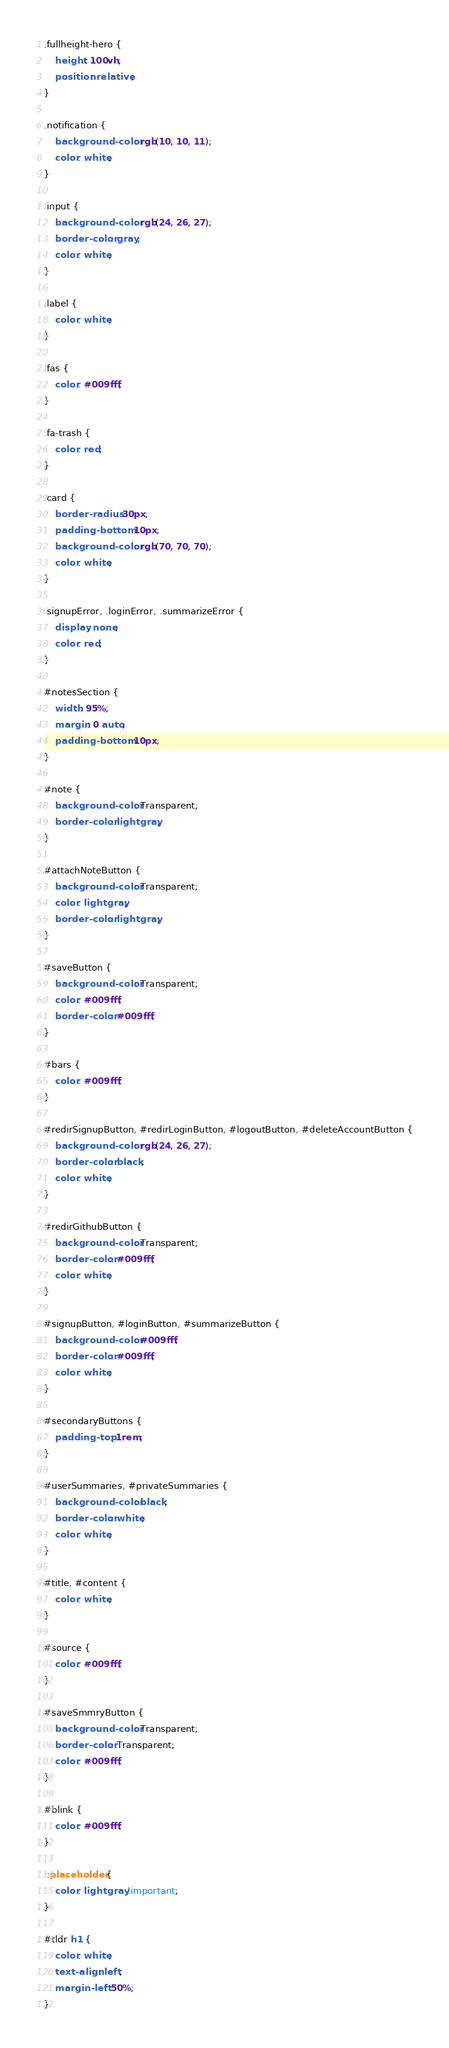<code> <loc_0><loc_0><loc_500><loc_500><_CSS_>.fullheight-hero {
    height: 100vh;
    position: relative;
}

.notification {
    background-color: rgb(10, 10, 11);
    color: white;
}

.input {
    background-color: rgb(24, 26, 27);
    border-color: gray;
    color: white;
}

.label {
    color: white;
}

.fas {
    color: #009fff;
}

.fa-trash {
    color: red;
}

.card {
    border-radius: 30px;
    padding-bottom: 10px;
    background-color: rgb(70, 70, 70);
    color: white;
}

.signupError, .loginError, .summarizeError {
    display: none;
    color: red;
}

#notesSection {
    width: 95%;
    margin: 0 auto;
    padding-bottom: 10px;
}

#note {
    background-color: Transparent;
    border-color: lightgray;
}

#attachNoteButton {
    background-color: Transparent;
    color: lightgray;
    border-color: lightgray;
}

#saveButton {
    background-color: Transparent;
    color: #009fff;
    border-color: #009fff;
}

#bars {
    color: #009fff;
}

#redirSignupButton, #redirLoginButton, #logoutButton, #deleteAccountButton {
    background-color: rgb(24, 26, 27);
    border-color: black;
    color: white;
}

#redirGithubButton {
    background-color: Transparent;
    border-color: #009fff;
    color: white;
}

#signupButton, #loginButton, #summarizeButton {
    background-color: #009fff;
    border-color: #009fff;
    color: white;
}

#secondaryButtons {
    padding-top: 1rem;
}

#userSummaries, #privateSummaries {
    background-color: black;
    border-color: white;
    color: white;
}

#title, #content {
    color: white;
}

#source {
    color: #009fff;
}

#saveSmmryButton {
    background-color: Transparent;
    border-color: Transparent;
    color: #009fff;
}

#blink {
    color: #009fff;
}

::placeholder {
    color: lightgray !important;
}

#tldr h1 {
    color: white;
    text-align: left;
    margin-left: 50%;
}
</code> 